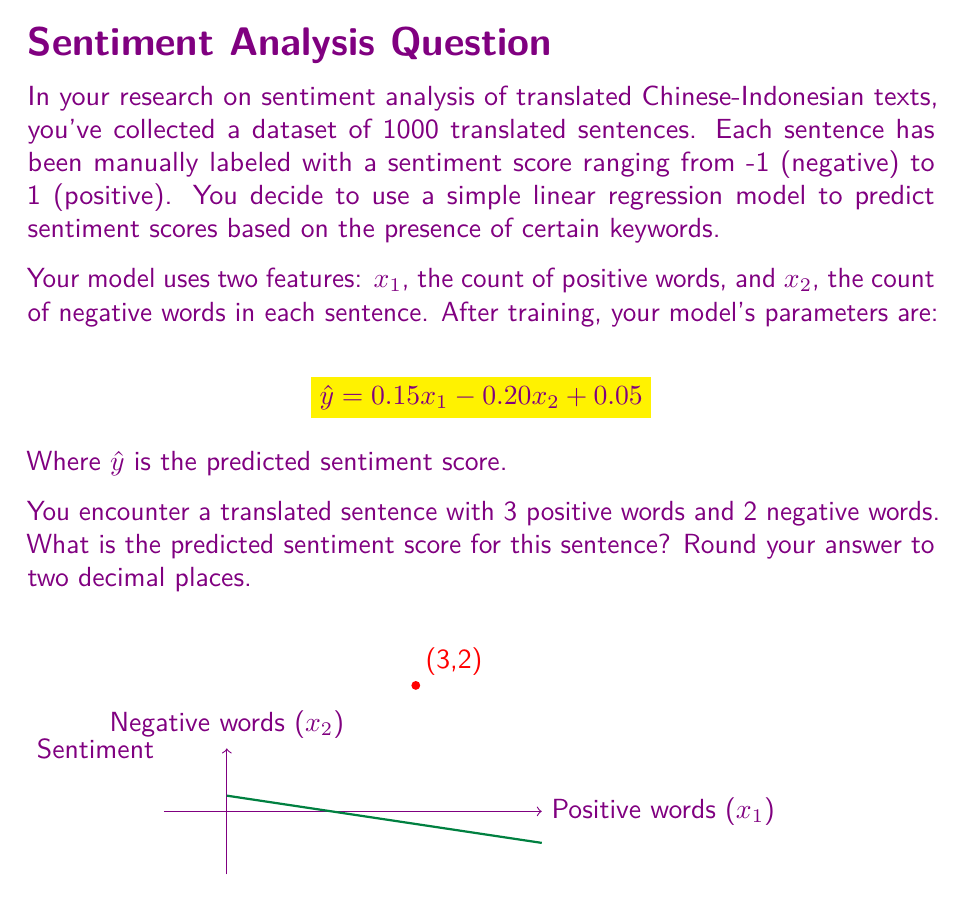Show me your answer to this math problem. Let's approach this step-by-step:

1) We are given the linear regression model:
   $$\hat{y} = 0.15x_1 - 0.20x_2 + 0.05$$

2) We need to substitute the values for $x_1$ and $x_2$:
   - $x_1 = 3$ (number of positive words)
   - $x_2 = 2$ (number of negative words)

3) Let's substitute these values into our equation:
   $$\hat{y} = 0.15(3) - 0.20(2) + 0.05$$

4) Now, let's solve this equation:
   $$\hat{y} = 0.45 - 0.40 + 0.05$$

5) Simplifying:
   $$\hat{y} = 0.10$$

6) The question asks to round to two decimal places, but 0.10 is already in that form.

Therefore, the predicted sentiment score for this sentence is 0.10.

This positive score indicates a slightly positive sentiment, which makes sense given that there are more positive words (3) than negative words (2) in the sentence. However, the score is close to neutral (0), reflecting that the difference in word counts is small.
Answer: 0.10 